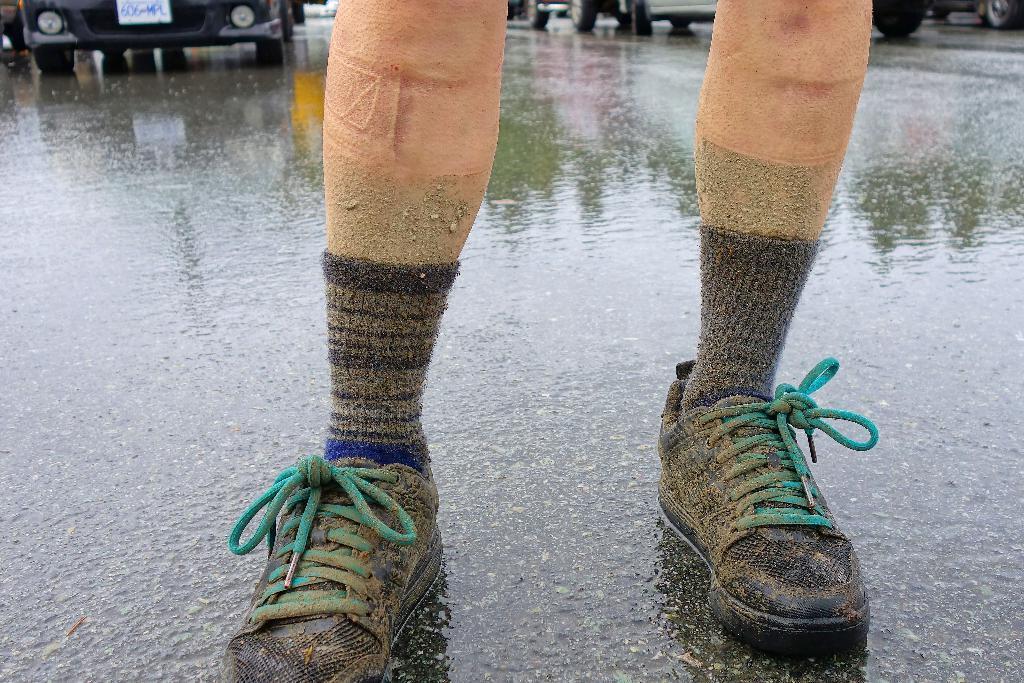Can you describe this image briefly? In this image we can see persons legs and few vehicles on the road. 